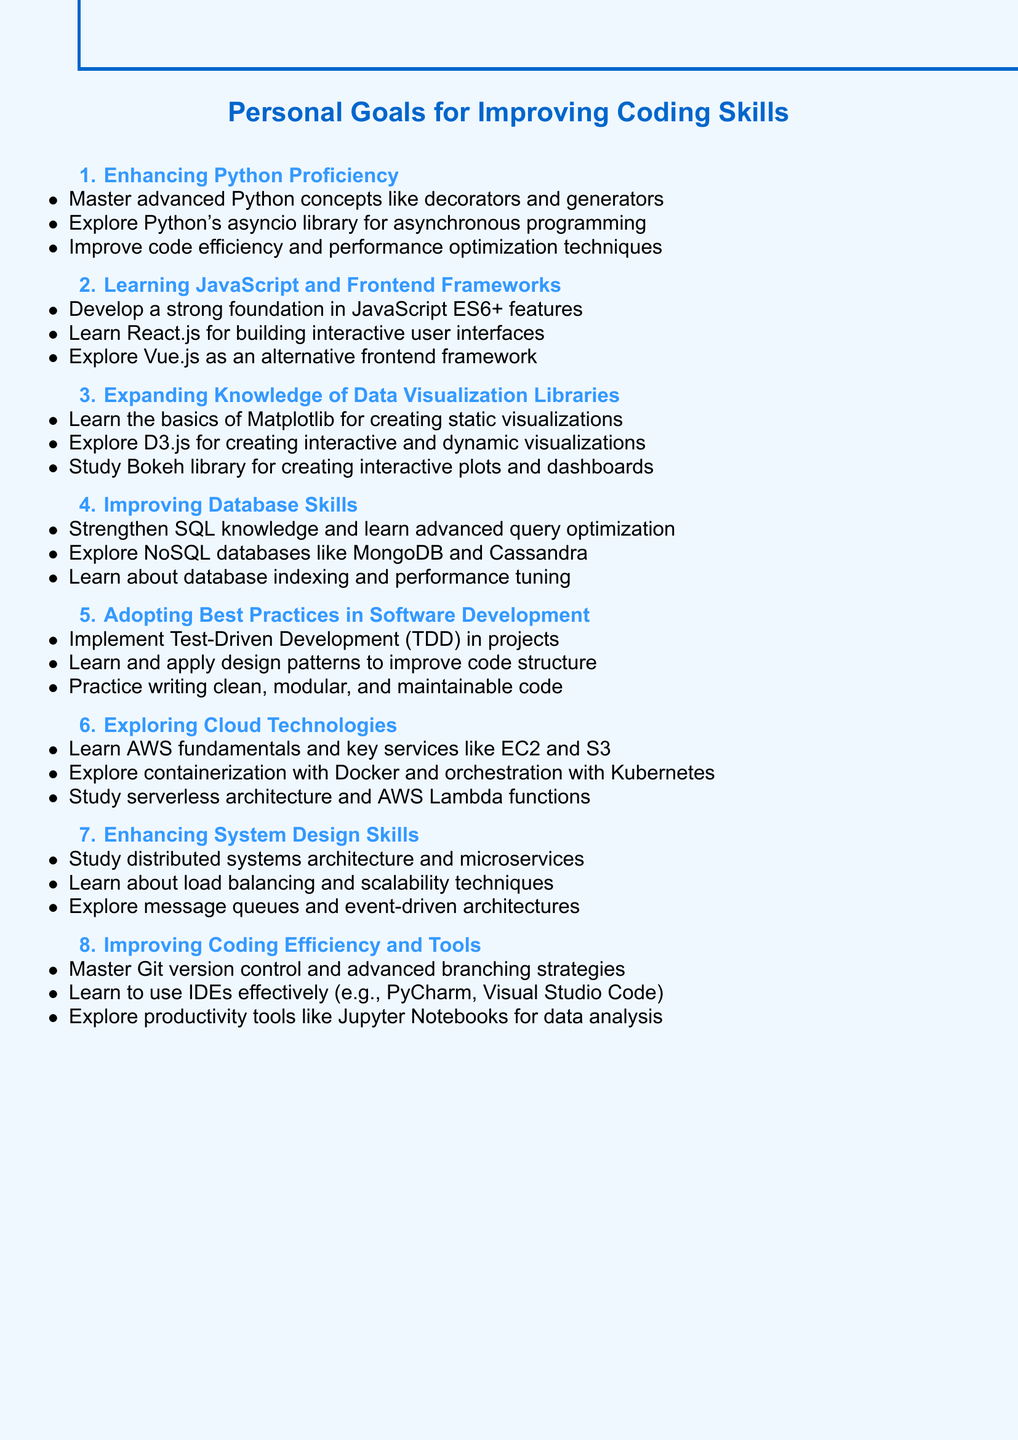What is the main topic of the document? The main topic is clearly stated at the beginning of the document, which is about personal goals related to coding skills and programming languages.
Answer: Personal goals for improving coding skills and learning new programming languages How many subtopics are included in the agenda? The document lists several subtopics, each highlighting a specific area of improvement. Counting them gives the total.
Answer: Eight What is the first point under "Enhancing Python proficiency"? The first point under this subtopic is specified in the agenda, detailing a particular focus area.
Answer: Master advanced Python concepts like decorators and generators Which JavaScript framework is mentioned for building interactive user interfaces? The document specifies React.js as a framework for a particular purpose in the context of learning JavaScript.
Answer: React.js What library is specifically mentioned for creating interactive plots? The agenda outlines specific libraries for data visualization, including one dedicated to creating interactive plots.
Answer: Bokeh What is one of the key services to learn under cloud technologies? The document mentions specific services provided by AWS that are important for understanding cloud technologies.
Answer: EC2 What practice should be implemented in software development according to the agenda? The document highlights a particular practice that is advocated for software development improvement.
Answer: Test-Driven Development (TDD) What is suggested for improving coding efficiency in tools? The document outlines specific tools and practices for enhancing coding efficiency and productivity.
Answer: Master Git version control and advanced branching strategies 